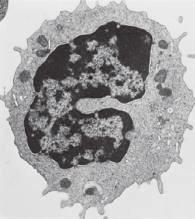when are the majority of tissue macrophages derived from hematopoietic precursors?
Answer the question using a single word or phrase. During inflammatory reactions 